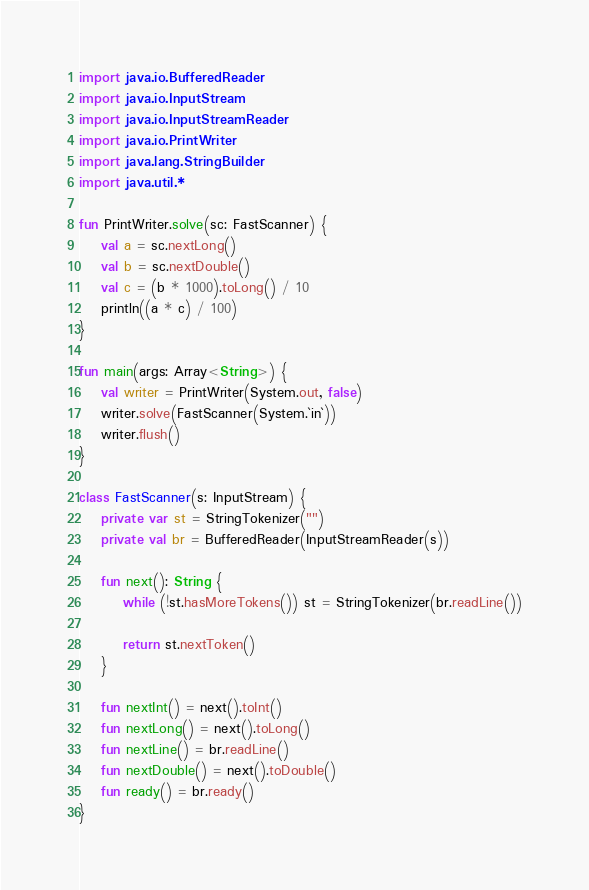<code> <loc_0><loc_0><loc_500><loc_500><_Kotlin_>import java.io.BufferedReader
import java.io.InputStream
import java.io.InputStreamReader
import java.io.PrintWriter
import java.lang.StringBuilder
import java.util.*

fun PrintWriter.solve(sc: FastScanner) {
    val a = sc.nextLong()
    val b = sc.nextDouble()
    val c = (b * 1000).toLong() / 10
    println((a * c) / 100)
}

fun main(args: Array<String>) {
    val writer = PrintWriter(System.out, false)
    writer.solve(FastScanner(System.`in`))
    writer.flush()
}

class FastScanner(s: InputStream) {
    private var st = StringTokenizer("")
    private val br = BufferedReader(InputStreamReader(s))

    fun next(): String {
        while (!st.hasMoreTokens()) st = StringTokenizer(br.readLine())

        return st.nextToken()
    }

    fun nextInt() = next().toInt()
    fun nextLong() = next().toLong()
    fun nextLine() = br.readLine()
    fun nextDouble() = next().toDouble()
    fun ready() = br.ready()
}
</code> 